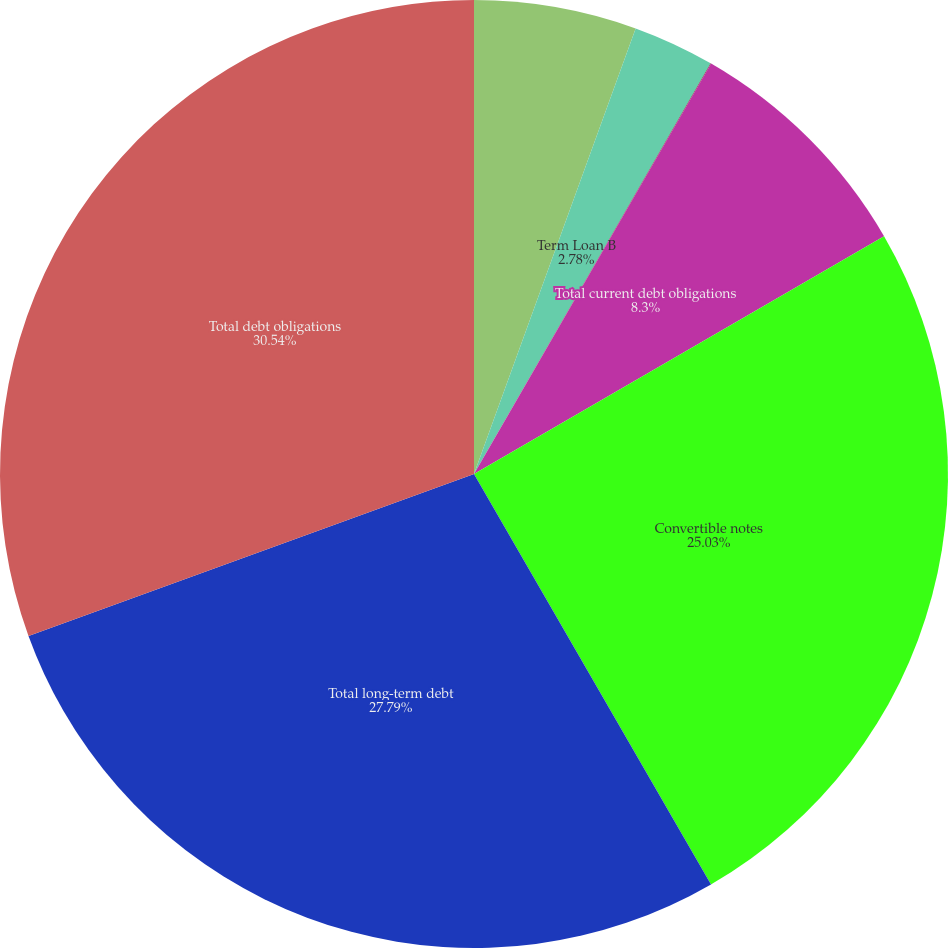Convert chart. <chart><loc_0><loc_0><loc_500><loc_500><pie_chart><fcel>Term Loan A<fcel>Term Loan B<fcel>AEG debt<fcel>Total current debt obligations<fcel>Convertible notes<fcel>Total long-term debt<fcel>Total debt obligations<nl><fcel>5.54%<fcel>2.78%<fcel>0.02%<fcel>8.3%<fcel>25.03%<fcel>27.79%<fcel>30.55%<nl></chart> 